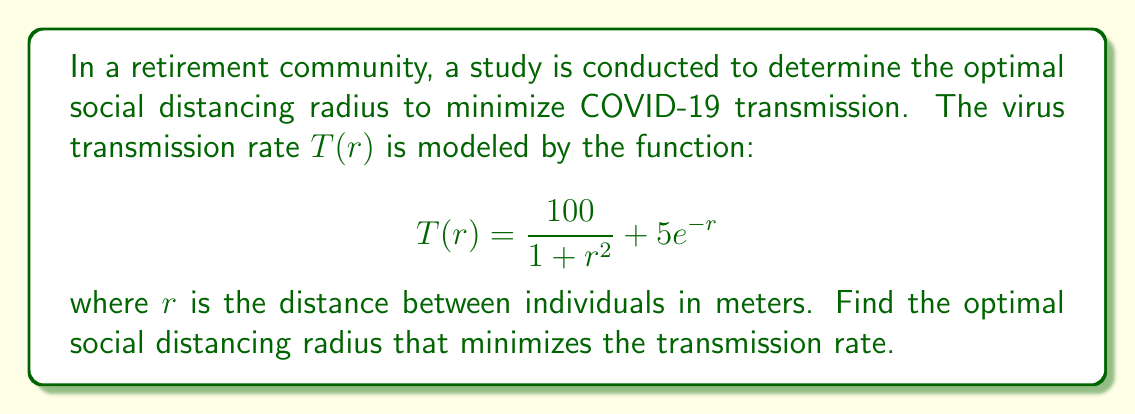Show me your answer to this math problem. To find the optimal social distancing radius, we need to minimize the transmission rate function $T(r)$. This can be done by finding the value of $r$ where the derivative of $T(r)$ equals zero.

1. First, let's calculate the derivative of $T(r)$:

   $$T'(r) = \frac{d}{dr}\left(\frac{100}{1 + r^2} + 5e^{-r}\right)$$
   $$T'(r) = -\frac{200r}{(1 + r^2)^2} - 5e^{-r}$$

2. Set the derivative equal to zero and solve for $r$:

   $$-\frac{200r}{(1 + r^2)^2} - 5e^{-r} = 0$$

3. This equation cannot be solved analytically, so we need to use numerical methods. We can use the Newton-Raphson method:

   $$r_{n+1} = r_n - \frac{f(r_n)}{f'(r_n)}$$

   where $f(r) = -\frac{200r}{(1 + r^2)^2} - 5e^{-r}$

   and $f'(r) = -\frac{200(1-r^2)}{(1 + r^2)^3} + 5e^{-r}$

4. Starting with an initial guess of $r_0 = 1$, we can iterate:

   $r_1 \approx 1.4142$
   $r_2 \approx 1.5811$
   $r_3 \approx 1.5955$
   $r_4 \approx 1.5957$

5. The iteration converges to $r \approx 1.5957$ meters.

6. To confirm this is a minimum, we can check the second derivative at this point:

   $$T''(r) = \frac{200(3r^2-1)}{(1 + r^2)^3} + 5e^{-r}$$

   At $r \approx 1.5957$, $T''(r) > 0$, confirming a local minimum.
Answer: The optimal social distancing radius to minimize COVID-19 transmission in the retirement community is approximately 1.60 meters (rounded to two decimal places). 